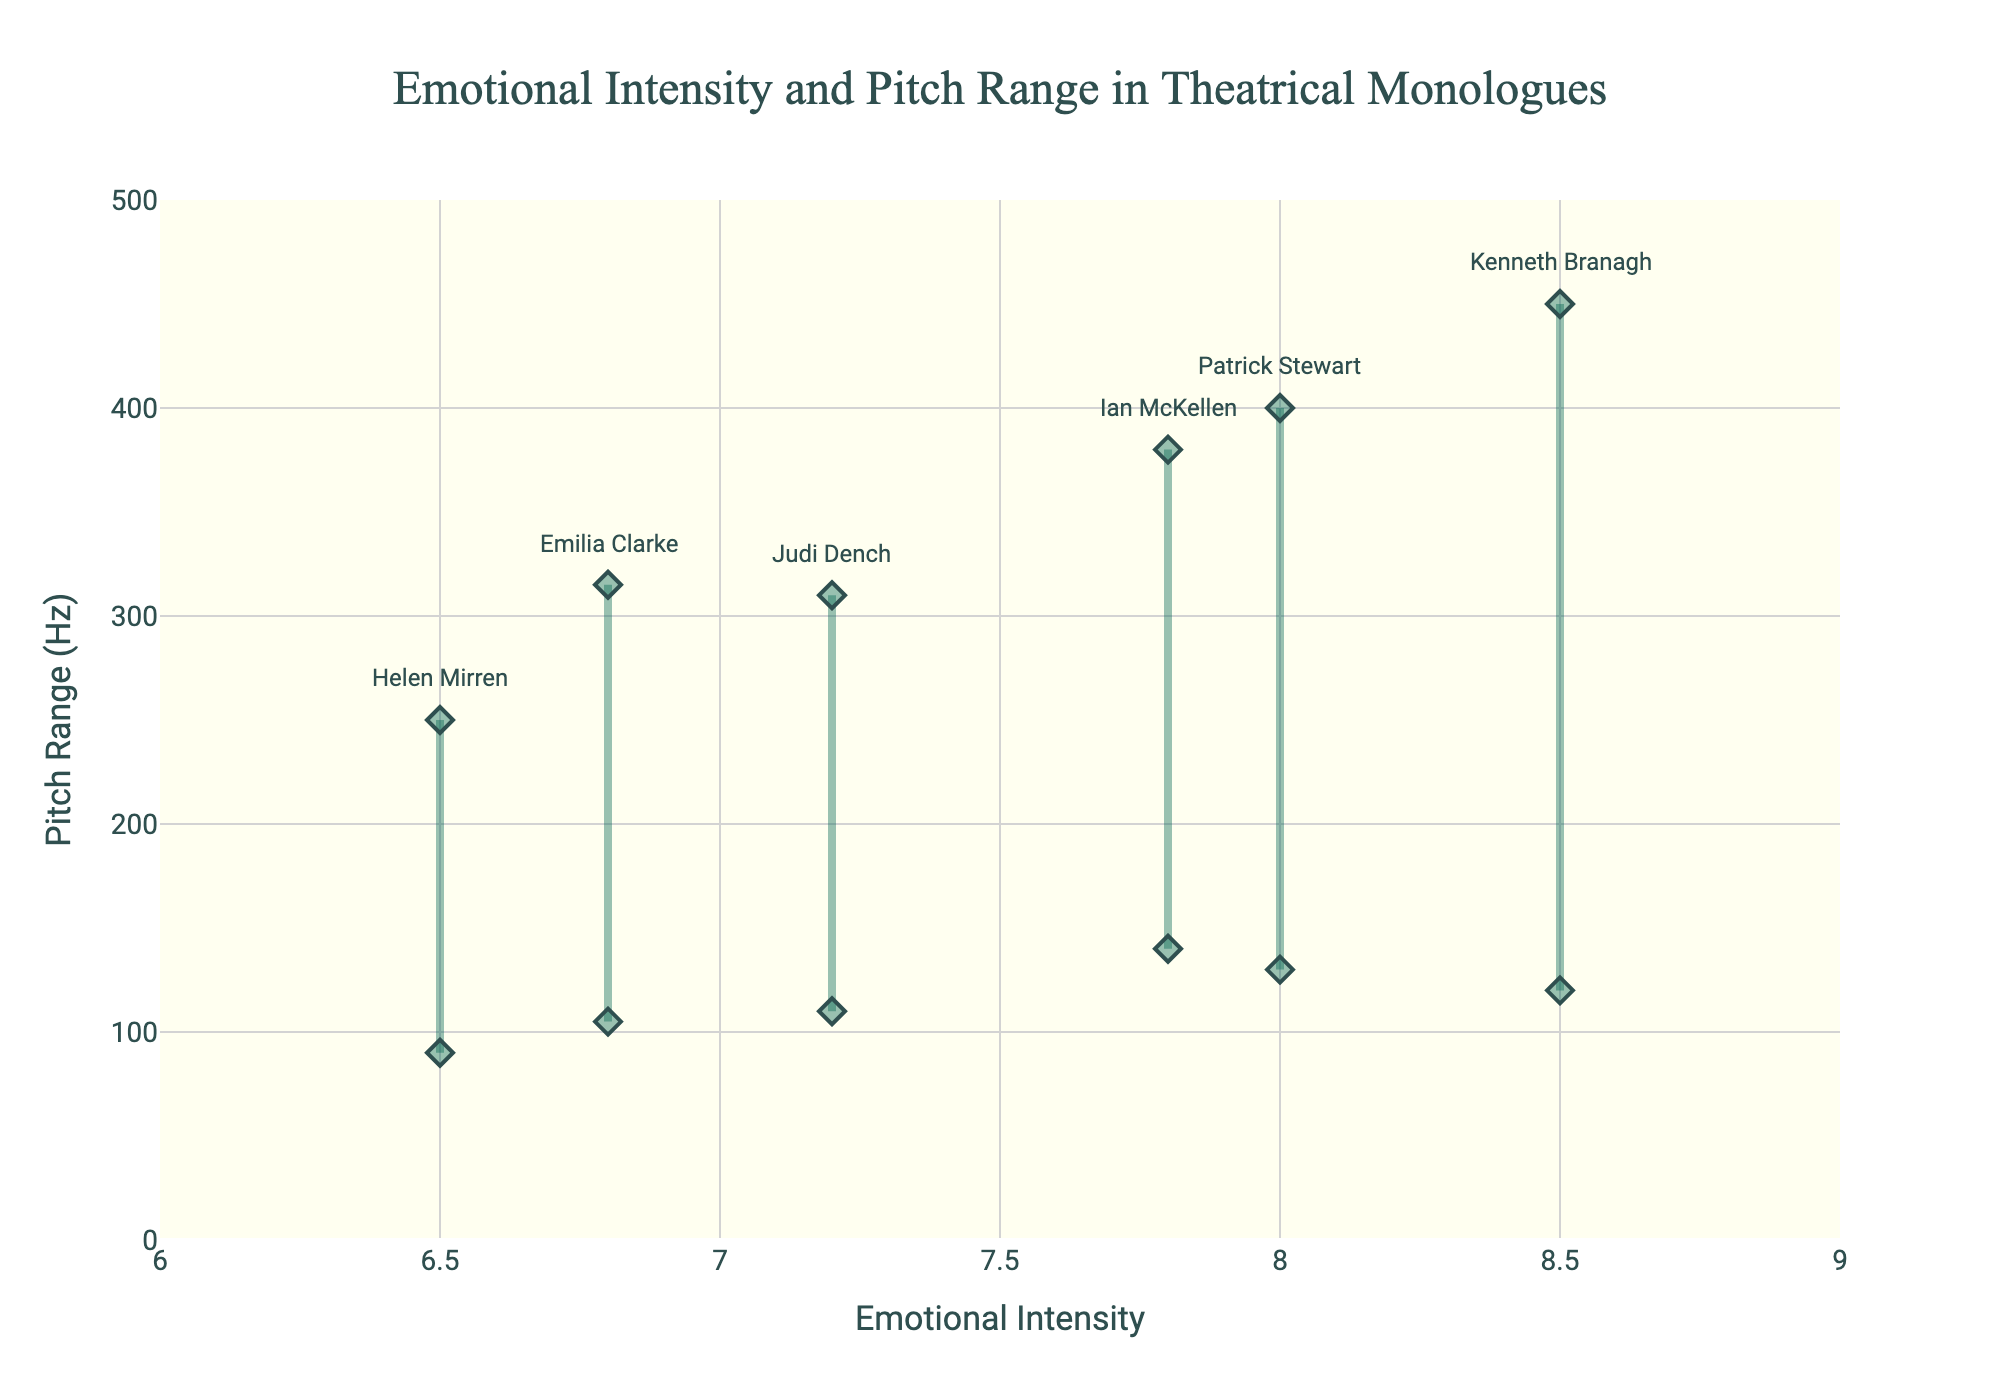what is the title of the figure? The title is positioned at the top center of the figure, showing a summary of the visual content.
Answer: Emotional Intensity and Pitch Range in Theatrical Monologues How many monologues are represented in the figure? Count the number of unique traces or data points in the chart, each representing a different monologue.
Answer: Six Which monologue has the highest emotional intensity? Look for the highest value on the x-axis (Emotional Intensity) among the plotted points.
Answer: To be or not to be What's the average pitch range (min to max) for all the monologues? Calculate the average pitch range by summing up the individual ranges (Pitch Max - Pitch Min) for each monologue and dividing by the total number of monologues. (330 for To be or not to be, 200 for My mistress' eyes are nothing like the sun, 240 for O wrathful day it will be, 160 for If we shadows have offended, 270 for Is that a dagger which I see before me, 210 for The quality of mercy is not strain'd; total 1410/6)
Answer: 235 Hz Which actor has the smallest pitch range in their monologue? Compare the pitch ranges (Pitch Max - Pitch Min) for each actor and identify the smallest one.
Answer: Helen Mirren Is there any monologue with an emotional intensity of exactly 7.0? Look at the x-axis values to see if there is any point plotted exactly at 7.0 on the emotional intensity scale.
Answer: No Is there a positive correlation between emotional intensity and pitch range in these monologues? Observe if higher values of emotional intensity on the x-axis generally correspond to higher pitch ranges (difference between Pitch Max and Pitch Min) on the y-axis. If no clear trend, state as such.
Answer: No clear trend Which monologue has the widest pitch range? Identify the monologue with the largest difference between Pitch Max and Pitch Min.
Answer: To be or not to be What is the pitch range of "O wrathful day it will be"? Locate the monologue "O wrathful day it will be" and subtract the Pitch Min from the Pitch Max. (380 - 140)
Answer: 240 Hz 